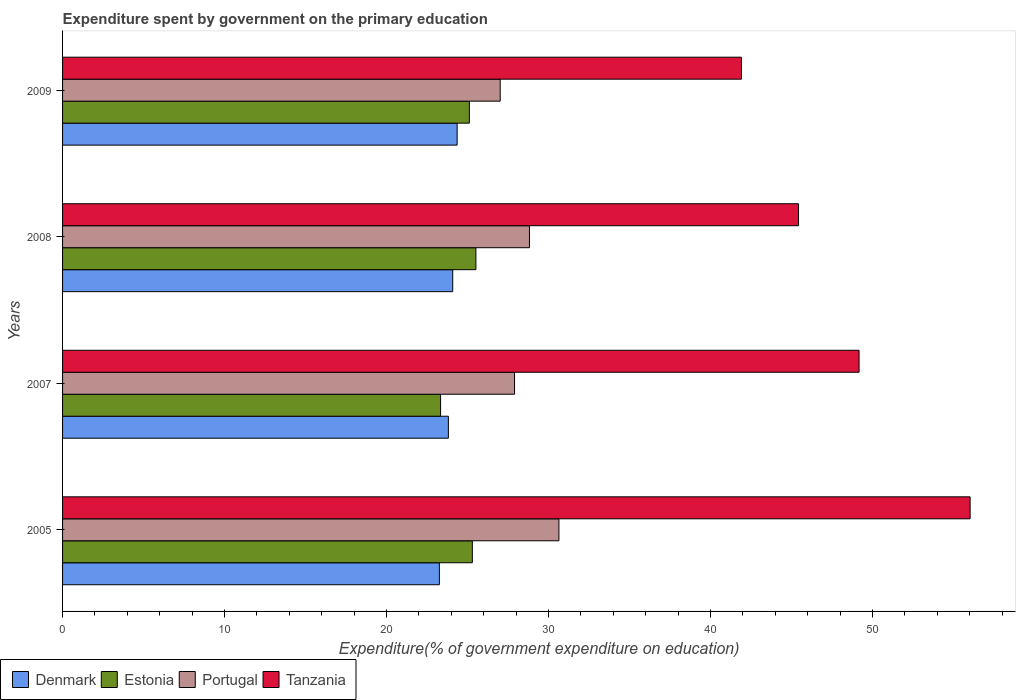How many different coloured bars are there?
Your response must be concise. 4. How many groups of bars are there?
Keep it short and to the point. 4. How many bars are there on the 1st tick from the top?
Provide a short and direct response. 4. In how many cases, is the number of bars for a given year not equal to the number of legend labels?
Provide a succinct answer. 0. What is the expenditure spent by government on the primary education in Tanzania in 2007?
Give a very brief answer. 49.17. Across all years, what is the maximum expenditure spent by government on the primary education in Estonia?
Keep it short and to the point. 25.52. Across all years, what is the minimum expenditure spent by government on the primary education in Estonia?
Provide a succinct answer. 23.33. In which year was the expenditure spent by government on the primary education in Estonia minimum?
Offer a very short reply. 2007. What is the total expenditure spent by government on the primary education in Estonia in the graph?
Your answer should be compact. 99.26. What is the difference between the expenditure spent by government on the primary education in Denmark in 2007 and that in 2009?
Provide a succinct answer. -0.54. What is the difference between the expenditure spent by government on the primary education in Estonia in 2009 and the expenditure spent by government on the primary education in Denmark in 2008?
Ensure brevity in your answer.  1.03. What is the average expenditure spent by government on the primary education in Tanzania per year?
Your answer should be compact. 48.13. In the year 2009, what is the difference between the expenditure spent by government on the primary education in Portugal and expenditure spent by government on the primary education in Denmark?
Your answer should be very brief. 2.66. What is the ratio of the expenditure spent by government on the primary education in Estonia in 2005 to that in 2008?
Offer a very short reply. 0.99. Is the expenditure spent by government on the primary education in Portugal in 2007 less than that in 2008?
Give a very brief answer. Yes. Is the difference between the expenditure spent by government on the primary education in Portugal in 2007 and 2008 greater than the difference between the expenditure spent by government on the primary education in Denmark in 2007 and 2008?
Offer a very short reply. No. What is the difference between the highest and the second highest expenditure spent by government on the primary education in Portugal?
Provide a short and direct response. 1.82. What is the difference between the highest and the lowest expenditure spent by government on the primary education in Portugal?
Ensure brevity in your answer.  3.63. What does the 1st bar from the top in 2005 represents?
Make the answer very short. Tanzania. What does the 4th bar from the bottom in 2009 represents?
Ensure brevity in your answer.  Tanzania. Is it the case that in every year, the sum of the expenditure spent by government on the primary education in Estonia and expenditure spent by government on the primary education in Denmark is greater than the expenditure spent by government on the primary education in Portugal?
Keep it short and to the point. Yes. How many bars are there?
Offer a very short reply. 16. What is the difference between two consecutive major ticks on the X-axis?
Keep it short and to the point. 10. Where does the legend appear in the graph?
Offer a terse response. Bottom left. How many legend labels are there?
Provide a short and direct response. 4. How are the legend labels stacked?
Offer a very short reply. Horizontal. What is the title of the graph?
Offer a very short reply. Expenditure spent by government on the primary education. Does "San Marino" appear as one of the legend labels in the graph?
Offer a terse response. No. What is the label or title of the X-axis?
Make the answer very short. Expenditure(% of government expenditure on education). What is the label or title of the Y-axis?
Your answer should be very brief. Years. What is the Expenditure(% of government expenditure on education) in Denmark in 2005?
Give a very brief answer. 23.26. What is the Expenditure(% of government expenditure on education) in Estonia in 2005?
Ensure brevity in your answer.  25.3. What is the Expenditure(% of government expenditure on education) of Portugal in 2005?
Your response must be concise. 30.64. What is the Expenditure(% of government expenditure on education) of Tanzania in 2005?
Give a very brief answer. 56.02. What is the Expenditure(% of government expenditure on education) in Denmark in 2007?
Ensure brevity in your answer.  23.82. What is the Expenditure(% of government expenditure on education) in Estonia in 2007?
Provide a succinct answer. 23.33. What is the Expenditure(% of government expenditure on education) in Portugal in 2007?
Your answer should be compact. 27.9. What is the Expenditure(% of government expenditure on education) of Tanzania in 2007?
Offer a very short reply. 49.17. What is the Expenditure(% of government expenditure on education) in Denmark in 2008?
Provide a succinct answer. 24.09. What is the Expenditure(% of government expenditure on education) in Estonia in 2008?
Give a very brief answer. 25.52. What is the Expenditure(% of government expenditure on education) of Portugal in 2008?
Offer a terse response. 28.82. What is the Expenditure(% of government expenditure on education) of Tanzania in 2008?
Keep it short and to the point. 45.43. What is the Expenditure(% of government expenditure on education) of Denmark in 2009?
Keep it short and to the point. 24.36. What is the Expenditure(% of government expenditure on education) in Estonia in 2009?
Offer a very short reply. 25.11. What is the Expenditure(% of government expenditure on education) of Portugal in 2009?
Your answer should be compact. 27.02. What is the Expenditure(% of government expenditure on education) in Tanzania in 2009?
Keep it short and to the point. 41.91. Across all years, what is the maximum Expenditure(% of government expenditure on education) of Denmark?
Your response must be concise. 24.36. Across all years, what is the maximum Expenditure(% of government expenditure on education) in Estonia?
Your answer should be very brief. 25.52. Across all years, what is the maximum Expenditure(% of government expenditure on education) in Portugal?
Provide a short and direct response. 30.64. Across all years, what is the maximum Expenditure(% of government expenditure on education) in Tanzania?
Your answer should be very brief. 56.02. Across all years, what is the minimum Expenditure(% of government expenditure on education) in Denmark?
Give a very brief answer. 23.26. Across all years, what is the minimum Expenditure(% of government expenditure on education) in Estonia?
Make the answer very short. 23.33. Across all years, what is the minimum Expenditure(% of government expenditure on education) in Portugal?
Your answer should be compact. 27.02. Across all years, what is the minimum Expenditure(% of government expenditure on education) in Tanzania?
Keep it short and to the point. 41.91. What is the total Expenditure(% of government expenditure on education) of Denmark in the graph?
Your answer should be compact. 95.52. What is the total Expenditure(% of government expenditure on education) of Estonia in the graph?
Make the answer very short. 99.26. What is the total Expenditure(% of government expenditure on education) of Portugal in the graph?
Ensure brevity in your answer.  114.38. What is the total Expenditure(% of government expenditure on education) in Tanzania in the graph?
Keep it short and to the point. 192.53. What is the difference between the Expenditure(% of government expenditure on education) in Denmark in 2005 and that in 2007?
Make the answer very short. -0.56. What is the difference between the Expenditure(% of government expenditure on education) in Estonia in 2005 and that in 2007?
Make the answer very short. 1.96. What is the difference between the Expenditure(% of government expenditure on education) in Portugal in 2005 and that in 2007?
Keep it short and to the point. 2.74. What is the difference between the Expenditure(% of government expenditure on education) of Tanzania in 2005 and that in 2007?
Keep it short and to the point. 6.85. What is the difference between the Expenditure(% of government expenditure on education) of Denmark in 2005 and that in 2008?
Keep it short and to the point. -0.83. What is the difference between the Expenditure(% of government expenditure on education) of Estonia in 2005 and that in 2008?
Your answer should be compact. -0.22. What is the difference between the Expenditure(% of government expenditure on education) of Portugal in 2005 and that in 2008?
Provide a short and direct response. 1.82. What is the difference between the Expenditure(% of government expenditure on education) of Tanzania in 2005 and that in 2008?
Offer a terse response. 10.59. What is the difference between the Expenditure(% of government expenditure on education) in Denmark in 2005 and that in 2009?
Make the answer very short. -1.1. What is the difference between the Expenditure(% of government expenditure on education) of Estonia in 2005 and that in 2009?
Provide a short and direct response. 0.18. What is the difference between the Expenditure(% of government expenditure on education) of Portugal in 2005 and that in 2009?
Your answer should be very brief. 3.62. What is the difference between the Expenditure(% of government expenditure on education) of Tanzania in 2005 and that in 2009?
Ensure brevity in your answer.  14.12. What is the difference between the Expenditure(% of government expenditure on education) in Denmark in 2007 and that in 2008?
Ensure brevity in your answer.  -0.27. What is the difference between the Expenditure(% of government expenditure on education) in Estonia in 2007 and that in 2008?
Make the answer very short. -2.18. What is the difference between the Expenditure(% of government expenditure on education) of Portugal in 2007 and that in 2008?
Your response must be concise. -0.92. What is the difference between the Expenditure(% of government expenditure on education) of Tanzania in 2007 and that in 2008?
Keep it short and to the point. 3.74. What is the difference between the Expenditure(% of government expenditure on education) of Denmark in 2007 and that in 2009?
Your answer should be compact. -0.54. What is the difference between the Expenditure(% of government expenditure on education) in Estonia in 2007 and that in 2009?
Your response must be concise. -1.78. What is the difference between the Expenditure(% of government expenditure on education) in Portugal in 2007 and that in 2009?
Provide a succinct answer. 0.89. What is the difference between the Expenditure(% of government expenditure on education) in Tanzania in 2007 and that in 2009?
Your answer should be very brief. 7.26. What is the difference between the Expenditure(% of government expenditure on education) of Denmark in 2008 and that in 2009?
Ensure brevity in your answer.  -0.27. What is the difference between the Expenditure(% of government expenditure on education) in Estonia in 2008 and that in 2009?
Make the answer very short. 0.4. What is the difference between the Expenditure(% of government expenditure on education) of Portugal in 2008 and that in 2009?
Make the answer very short. 1.81. What is the difference between the Expenditure(% of government expenditure on education) in Tanzania in 2008 and that in 2009?
Your answer should be very brief. 3.53. What is the difference between the Expenditure(% of government expenditure on education) of Denmark in 2005 and the Expenditure(% of government expenditure on education) of Estonia in 2007?
Your answer should be very brief. -0.07. What is the difference between the Expenditure(% of government expenditure on education) of Denmark in 2005 and the Expenditure(% of government expenditure on education) of Portugal in 2007?
Ensure brevity in your answer.  -4.64. What is the difference between the Expenditure(% of government expenditure on education) in Denmark in 2005 and the Expenditure(% of government expenditure on education) in Tanzania in 2007?
Make the answer very short. -25.91. What is the difference between the Expenditure(% of government expenditure on education) of Estonia in 2005 and the Expenditure(% of government expenditure on education) of Portugal in 2007?
Provide a succinct answer. -2.6. What is the difference between the Expenditure(% of government expenditure on education) of Estonia in 2005 and the Expenditure(% of government expenditure on education) of Tanzania in 2007?
Provide a succinct answer. -23.87. What is the difference between the Expenditure(% of government expenditure on education) of Portugal in 2005 and the Expenditure(% of government expenditure on education) of Tanzania in 2007?
Give a very brief answer. -18.53. What is the difference between the Expenditure(% of government expenditure on education) in Denmark in 2005 and the Expenditure(% of government expenditure on education) in Estonia in 2008?
Provide a succinct answer. -2.26. What is the difference between the Expenditure(% of government expenditure on education) in Denmark in 2005 and the Expenditure(% of government expenditure on education) in Portugal in 2008?
Give a very brief answer. -5.56. What is the difference between the Expenditure(% of government expenditure on education) of Denmark in 2005 and the Expenditure(% of government expenditure on education) of Tanzania in 2008?
Offer a terse response. -22.17. What is the difference between the Expenditure(% of government expenditure on education) of Estonia in 2005 and the Expenditure(% of government expenditure on education) of Portugal in 2008?
Give a very brief answer. -3.53. What is the difference between the Expenditure(% of government expenditure on education) of Estonia in 2005 and the Expenditure(% of government expenditure on education) of Tanzania in 2008?
Provide a short and direct response. -20.14. What is the difference between the Expenditure(% of government expenditure on education) in Portugal in 2005 and the Expenditure(% of government expenditure on education) in Tanzania in 2008?
Your response must be concise. -14.79. What is the difference between the Expenditure(% of government expenditure on education) in Denmark in 2005 and the Expenditure(% of government expenditure on education) in Estonia in 2009?
Offer a very short reply. -1.85. What is the difference between the Expenditure(% of government expenditure on education) of Denmark in 2005 and the Expenditure(% of government expenditure on education) of Portugal in 2009?
Offer a very short reply. -3.75. What is the difference between the Expenditure(% of government expenditure on education) of Denmark in 2005 and the Expenditure(% of government expenditure on education) of Tanzania in 2009?
Ensure brevity in your answer.  -18.65. What is the difference between the Expenditure(% of government expenditure on education) in Estonia in 2005 and the Expenditure(% of government expenditure on education) in Portugal in 2009?
Offer a terse response. -1.72. What is the difference between the Expenditure(% of government expenditure on education) in Estonia in 2005 and the Expenditure(% of government expenditure on education) in Tanzania in 2009?
Provide a succinct answer. -16.61. What is the difference between the Expenditure(% of government expenditure on education) of Portugal in 2005 and the Expenditure(% of government expenditure on education) of Tanzania in 2009?
Offer a terse response. -11.27. What is the difference between the Expenditure(% of government expenditure on education) of Denmark in 2007 and the Expenditure(% of government expenditure on education) of Estonia in 2008?
Your answer should be very brief. -1.7. What is the difference between the Expenditure(% of government expenditure on education) of Denmark in 2007 and the Expenditure(% of government expenditure on education) of Portugal in 2008?
Your answer should be compact. -5.01. What is the difference between the Expenditure(% of government expenditure on education) in Denmark in 2007 and the Expenditure(% of government expenditure on education) in Tanzania in 2008?
Provide a short and direct response. -21.62. What is the difference between the Expenditure(% of government expenditure on education) in Estonia in 2007 and the Expenditure(% of government expenditure on education) in Portugal in 2008?
Offer a very short reply. -5.49. What is the difference between the Expenditure(% of government expenditure on education) of Estonia in 2007 and the Expenditure(% of government expenditure on education) of Tanzania in 2008?
Give a very brief answer. -22.1. What is the difference between the Expenditure(% of government expenditure on education) of Portugal in 2007 and the Expenditure(% of government expenditure on education) of Tanzania in 2008?
Your answer should be very brief. -17.53. What is the difference between the Expenditure(% of government expenditure on education) in Denmark in 2007 and the Expenditure(% of government expenditure on education) in Estonia in 2009?
Ensure brevity in your answer.  -1.3. What is the difference between the Expenditure(% of government expenditure on education) of Denmark in 2007 and the Expenditure(% of government expenditure on education) of Portugal in 2009?
Your answer should be very brief. -3.2. What is the difference between the Expenditure(% of government expenditure on education) in Denmark in 2007 and the Expenditure(% of government expenditure on education) in Tanzania in 2009?
Provide a short and direct response. -18.09. What is the difference between the Expenditure(% of government expenditure on education) of Estonia in 2007 and the Expenditure(% of government expenditure on education) of Portugal in 2009?
Provide a succinct answer. -3.68. What is the difference between the Expenditure(% of government expenditure on education) of Estonia in 2007 and the Expenditure(% of government expenditure on education) of Tanzania in 2009?
Keep it short and to the point. -18.57. What is the difference between the Expenditure(% of government expenditure on education) in Portugal in 2007 and the Expenditure(% of government expenditure on education) in Tanzania in 2009?
Ensure brevity in your answer.  -14.01. What is the difference between the Expenditure(% of government expenditure on education) in Denmark in 2008 and the Expenditure(% of government expenditure on education) in Estonia in 2009?
Keep it short and to the point. -1.03. What is the difference between the Expenditure(% of government expenditure on education) in Denmark in 2008 and the Expenditure(% of government expenditure on education) in Portugal in 2009?
Provide a short and direct response. -2.93. What is the difference between the Expenditure(% of government expenditure on education) in Denmark in 2008 and the Expenditure(% of government expenditure on education) in Tanzania in 2009?
Your answer should be very brief. -17.82. What is the difference between the Expenditure(% of government expenditure on education) of Estonia in 2008 and the Expenditure(% of government expenditure on education) of Portugal in 2009?
Your response must be concise. -1.5. What is the difference between the Expenditure(% of government expenditure on education) in Estonia in 2008 and the Expenditure(% of government expenditure on education) in Tanzania in 2009?
Provide a succinct answer. -16.39. What is the difference between the Expenditure(% of government expenditure on education) of Portugal in 2008 and the Expenditure(% of government expenditure on education) of Tanzania in 2009?
Provide a succinct answer. -13.08. What is the average Expenditure(% of government expenditure on education) in Denmark per year?
Offer a terse response. 23.88. What is the average Expenditure(% of government expenditure on education) in Estonia per year?
Keep it short and to the point. 24.81. What is the average Expenditure(% of government expenditure on education) of Portugal per year?
Offer a very short reply. 28.59. What is the average Expenditure(% of government expenditure on education) of Tanzania per year?
Provide a short and direct response. 48.13. In the year 2005, what is the difference between the Expenditure(% of government expenditure on education) in Denmark and Expenditure(% of government expenditure on education) in Estonia?
Offer a very short reply. -2.04. In the year 2005, what is the difference between the Expenditure(% of government expenditure on education) in Denmark and Expenditure(% of government expenditure on education) in Portugal?
Your response must be concise. -7.38. In the year 2005, what is the difference between the Expenditure(% of government expenditure on education) of Denmark and Expenditure(% of government expenditure on education) of Tanzania?
Offer a terse response. -32.76. In the year 2005, what is the difference between the Expenditure(% of government expenditure on education) in Estonia and Expenditure(% of government expenditure on education) in Portugal?
Offer a terse response. -5.34. In the year 2005, what is the difference between the Expenditure(% of government expenditure on education) in Estonia and Expenditure(% of government expenditure on education) in Tanzania?
Make the answer very short. -30.73. In the year 2005, what is the difference between the Expenditure(% of government expenditure on education) of Portugal and Expenditure(% of government expenditure on education) of Tanzania?
Your answer should be compact. -25.38. In the year 2007, what is the difference between the Expenditure(% of government expenditure on education) of Denmark and Expenditure(% of government expenditure on education) of Estonia?
Give a very brief answer. 0.48. In the year 2007, what is the difference between the Expenditure(% of government expenditure on education) in Denmark and Expenditure(% of government expenditure on education) in Portugal?
Your answer should be very brief. -4.08. In the year 2007, what is the difference between the Expenditure(% of government expenditure on education) in Denmark and Expenditure(% of government expenditure on education) in Tanzania?
Your response must be concise. -25.35. In the year 2007, what is the difference between the Expenditure(% of government expenditure on education) in Estonia and Expenditure(% of government expenditure on education) in Portugal?
Offer a terse response. -4.57. In the year 2007, what is the difference between the Expenditure(% of government expenditure on education) of Estonia and Expenditure(% of government expenditure on education) of Tanzania?
Provide a succinct answer. -25.83. In the year 2007, what is the difference between the Expenditure(% of government expenditure on education) in Portugal and Expenditure(% of government expenditure on education) in Tanzania?
Provide a short and direct response. -21.27. In the year 2008, what is the difference between the Expenditure(% of government expenditure on education) in Denmark and Expenditure(% of government expenditure on education) in Estonia?
Make the answer very short. -1.43. In the year 2008, what is the difference between the Expenditure(% of government expenditure on education) of Denmark and Expenditure(% of government expenditure on education) of Portugal?
Offer a terse response. -4.74. In the year 2008, what is the difference between the Expenditure(% of government expenditure on education) in Denmark and Expenditure(% of government expenditure on education) in Tanzania?
Ensure brevity in your answer.  -21.35. In the year 2008, what is the difference between the Expenditure(% of government expenditure on education) of Estonia and Expenditure(% of government expenditure on education) of Portugal?
Offer a very short reply. -3.31. In the year 2008, what is the difference between the Expenditure(% of government expenditure on education) in Estonia and Expenditure(% of government expenditure on education) in Tanzania?
Offer a very short reply. -19.92. In the year 2008, what is the difference between the Expenditure(% of government expenditure on education) in Portugal and Expenditure(% of government expenditure on education) in Tanzania?
Make the answer very short. -16.61. In the year 2009, what is the difference between the Expenditure(% of government expenditure on education) in Denmark and Expenditure(% of government expenditure on education) in Estonia?
Your response must be concise. -0.76. In the year 2009, what is the difference between the Expenditure(% of government expenditure on education) in Denmark and Expenditure(% of government expenditure on education) in Portugal?
Keep it short and to the point. -2.66. In the year 2009, what is the difference between the Expenditure(% of government expenditure on education) in Denmark and Expenditure(% of government expenditure on education) in Tanzania?
Your response must be concise. -17.55. In the year 2009, what is the difference between the Expenditure(% of government expenditure on education) in Estonia and Expenditure(% of government expenditure on education) in Portugal?
Keep it short and to the point. -1.9. In the year 2009, what is the difference between the Expenditure(% of government expenditure on education) of Estonia and Expenditure(% of government expenditure on education) of Tanzania?
Offer a very short reply. -16.79. In the year 2009, what is the difference between the Expenditure(% of government expenditure on education) in Portugal and Expenditure(% of government expenditure on education) in Tanzania?
Your response must be concise. -14.89. What is the ratio of the Expenditure(% of government expenditure on education) of Denmark in 2005 to that in 2007?
Your response must be concise. 0.98. What is the ratio of the Expenditure(% of government expenditure on education) in Estonia in 2005 to that in 2007?
Offer a very short reply. 1.08. What is the ratio of the Expenditure(% of government expenditure on education) in Portugal in 2005 to that in 2007?
Provide a short and direct response. 1.1. What is the ratio of the Expenditure(% of government expenditure on education) in Tanzania in 2005 to that in 2007?
Your response must be concise. 1.14. What is the ratio of the Expenditure(% of government expenditure on education) in Denmark in 2005 to that in 2008?
Provide a succinct answer. 0.97. What is the ratio of the Expenditure(% of government expenditure on education) in Estonia in 2005 to that in 2008?
Your answer should be very brief. 0.99. What is the ratio of the Expenditure(% of government expenditure on education) of Portugal in 2005 to that in 2008?
Keep it short and to the point. 1.06. What is the ratio of the Expenditure(% of government expenditure on education) of Tanzania in 2005 to that in 2008?
Make the answer very short. 1.23. What is the ratio of the Expenditure(% of government expenditure on education) of Denmark in 2005 to that in 2009?
Your answer should be compact. 0.95. What is the ratio of the Expenditure(% of government expenditure on education) in Estonia in 2005 to that in 2009?
Keep it short and to the point. 1.01. What is the ratio of the Expenditure(% of government expenditure on education) of Portugal in 2005 to that in 2009?
Your answer should be compact. 1.13. What is the ratio of the Expenditure(% of government expenditure on education) in Tanzania in 2005 to that in 2009?
Your answer should be compact. 1.34. What is the ratio of the Expenditure(% of government expenditure on education) of Denmark in 2007 to that in 2008?
Your answer should be very brief. 0.99. What is the ratio of the Expenditure(% of government expenditure on education) in Estonia in 2007 to that in 2008?
Offer a terse response. 0.91. What is the ratio of the Expenditure(% of government expenditure on education) of Portugal in 2007 to that in 2008?
Give a very brief answer. 0.97. What is the ratio of the Expenditure(% of government expenditure on education) of Tanzania in 2007 to that in 2008?
Keep it short and to the point. 1.08. What is the ratio of the Expenditure(% of government expenditure on education) of Denmark in 2007 to that in 2009?
Your response must be concise. 0.98. What is the ratio of the Expenditure(% of government expenditure on education) in Estonia in 2007 to that in 2009?
Keep it short and to the point. 0.93. What is the ratio of the Expenditure(% of government expenditure on education) of Portugal in 2007 to that in 2009?
Give a very brief answer. 1.03. What is the ratio of the Expenditure(% of government expenditure on education) in Tanzania in 2007 to that in 2009?
Your answer should be compact. 1.17. What is the ratio of the Expenditure(% of government expenditure on education) in Denmark in 2008 to that in 2009?
Provide a short and direct response. 0.99. What is the ratio of the Expenditure(% of government expenditure on education) of Estonia in 2008 to that in 2009?
Offer a very short reply. 1.02. What is the ratio of the Expenditure(% of government expenditure on education) in Portugal in 2008 to that in 2009?
Your answer should be very brief. 1.07. What is the ratio of the Expenditure(% of government expenditure on education) in Tanzania in 2008 to that in 2009?
Your response must be concise. 1.08. What is the difference between the highest and the second highest Expenditure(% of government expenditure on education) in Denmark?
Your response must be concise. 0.27. What is the difference between the highest and the second highest Expenditure(% of government expenditure on education) of Estonia?
Give a very brief answer. 0.22. What is the difference between the highest and the second highest Expenditure(% of government expenditure on education) in Portugal?
Keep it short and to the point. 1.82. What is the difference between the highest and the second highest Expenditure(% of government expenditure on education) in Tanzania?
Offer a terse response. 6.85. What is the difference between the highest and the lowest Expenditure(% of government expenditure on education) in Denmark?
Give a very brief answer. 1.1. What is the difference between the highest and the lowest Expenditure(% of government expenditure on education) of Estonia?
Ensure brevity in your answer.  2.18. What is the difference between the highest and the lowest Expenditure(% of government expenditure on education) of Portugal?
Ensure brevity in your answer.  3.62. What is the difference between the highest and the lowest Expenditure(% of government expenditure on education) of Tanzania?
Keep it short and to the point. 14.12. 